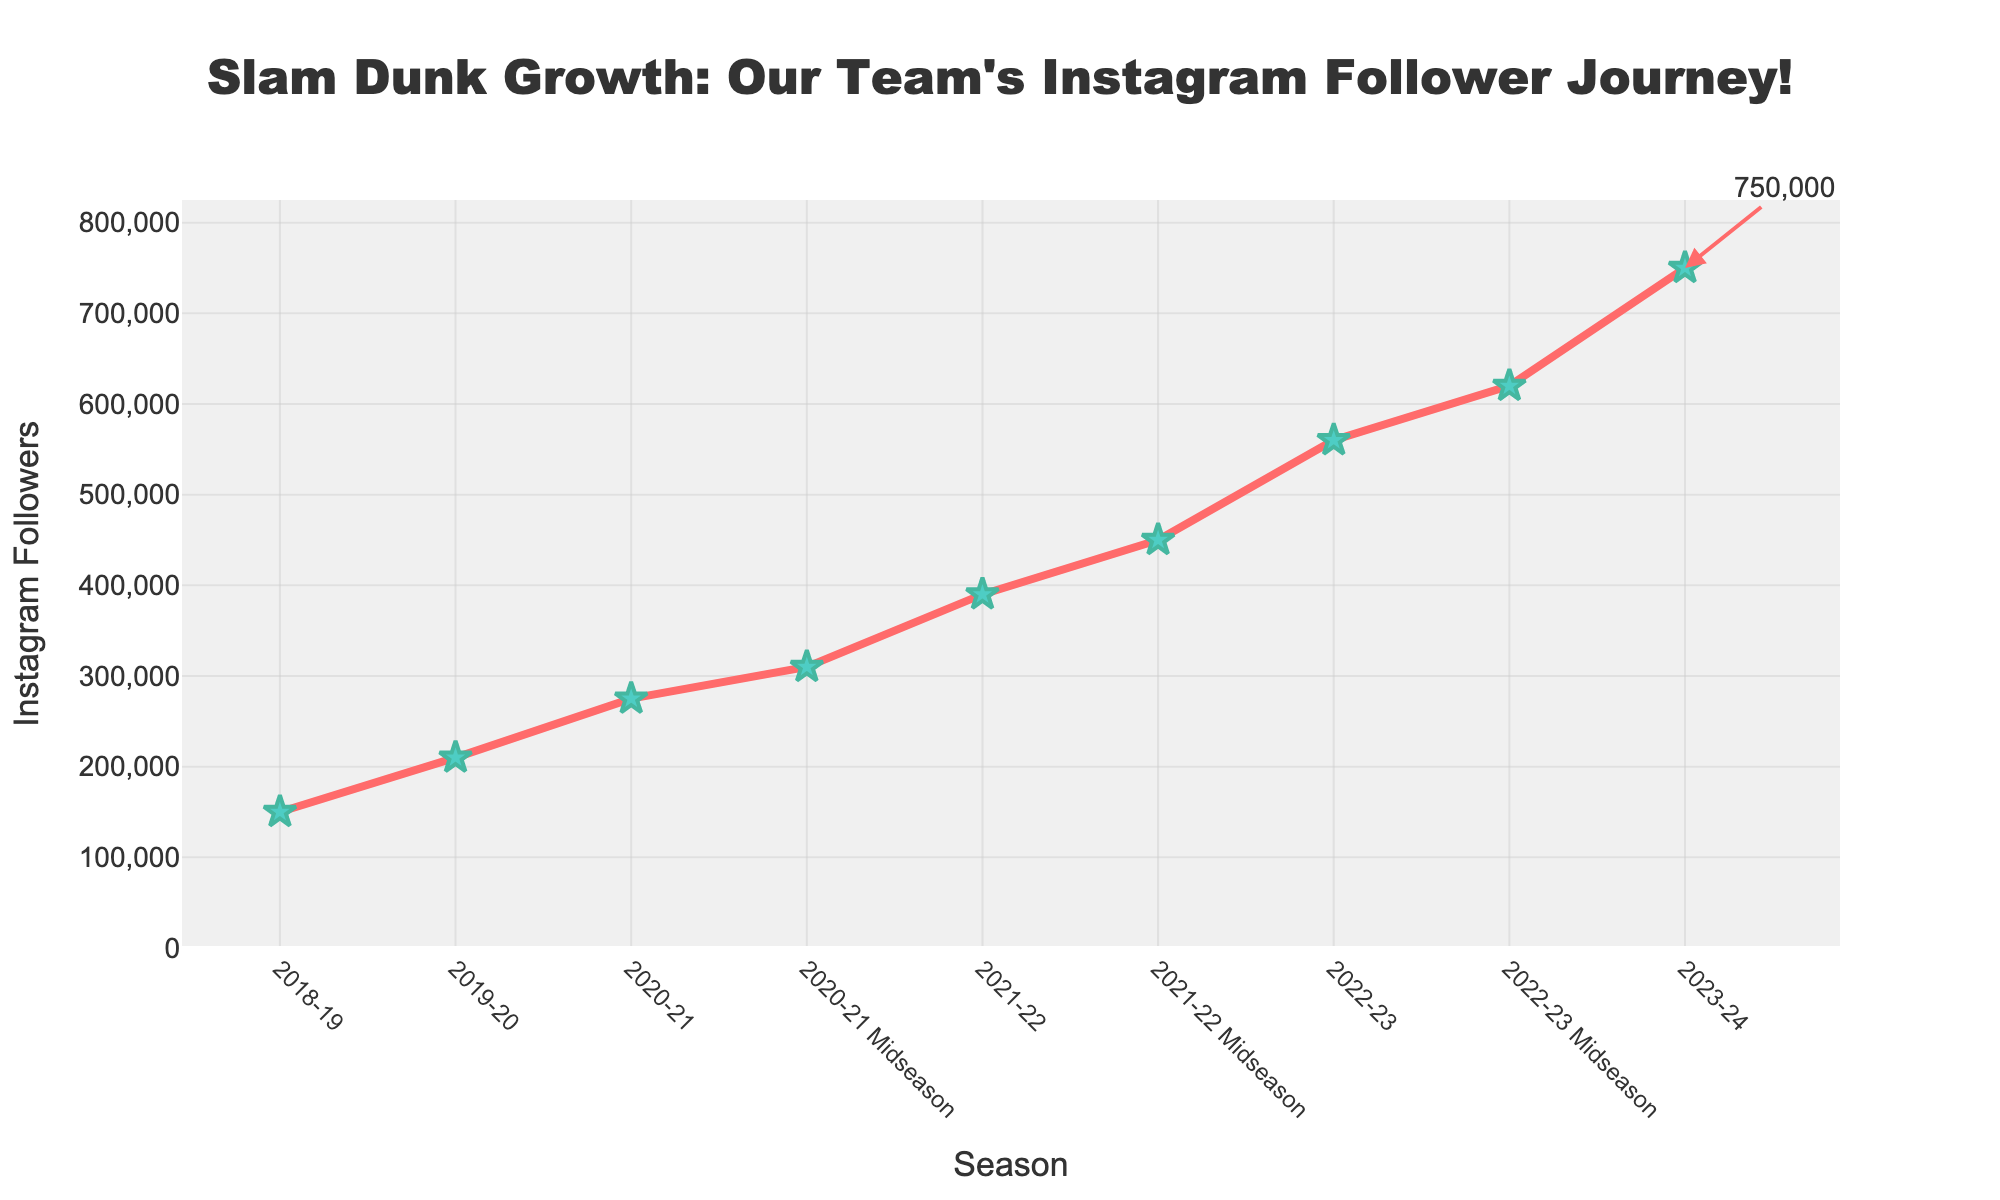What season had the highest number of Instagram followers at the start of the season? The season with the highest number of Instagram followers at the start is the season where the y-value (Instagram followers) at the beginning of the season is the highest. Based on the figure, the 2023-24 season had the highest number of Instagram followers at the beginning of the season.
Answer: 2023-24 Which season saw the largest increase in Instagram followers by midseason? To determine this, look at the differences in Instagram followers at midseason and the start for each season. Compare the differences and the largest one will indicate the season with the highest increase. From 2022-23 start (560,000) to midseason (620,000) is an increase of 60,000, which is the largest increase among the seasons.
Answer: 2022-23 How many followers were there around midseason in 2021-22? Locate the midseason point for 2021-22 on the x-axis and read the corresponding y-value. The figure shows the midseason followers for 2021-22 to be 450,000.
Answer: 450,000 What was the growth in Instagram followers from the beginning to the end of the 2018-19 season? Calculate the difference between the Instagram followers at the beginning and end of the 2018-19 season. Since no midseason data is provided for 2018-19, use the data at start and end. The followers grew from 150,000 to 210,000, which is an increase of 60,000.
Answer: 60,000 In which midseason did the followers first exceed 300,000? Look for the midseason data points and find the first midseason where the y-value (followers) exceeds 300,000. The midseason of 2020-21 shows followers exceeding 300,000 for the first time, with a value of 310,000.
Answer: 2020-21 Midseason What is the percentage increase in Instagram followers from the start to midseason of 2022-23? Calculate the percentage increase using the formula: (Midseason value - start value) / start value * 100. For 2022-23, it is (620,000 - 560,000) / 560,000 * 100, resulting in approximately 10.71%.
Answer: 10.71% Which season had the smallest growth in followers from start to end? Compare the differences in Instagram followers from start to end for each season. The season with the smallest difference indicates the smallest growth. For 2018-19, the growth is 60,000 (150,000 to 210,000), the smallest among all seasons.
Answer: 2018-19 What was the average number of Instagram followers at midseason across all years with midseason data? Sum the midseason followers of all seasons with midseason data and divide by the count of those seasons. The total midseason followers are (310,000 + 450,000 + 620,000) = 1,380,000. There are 3 seasons with midseason data, so the average is 1,380,000 / 3 = 460,000.
Answer: 460,000 